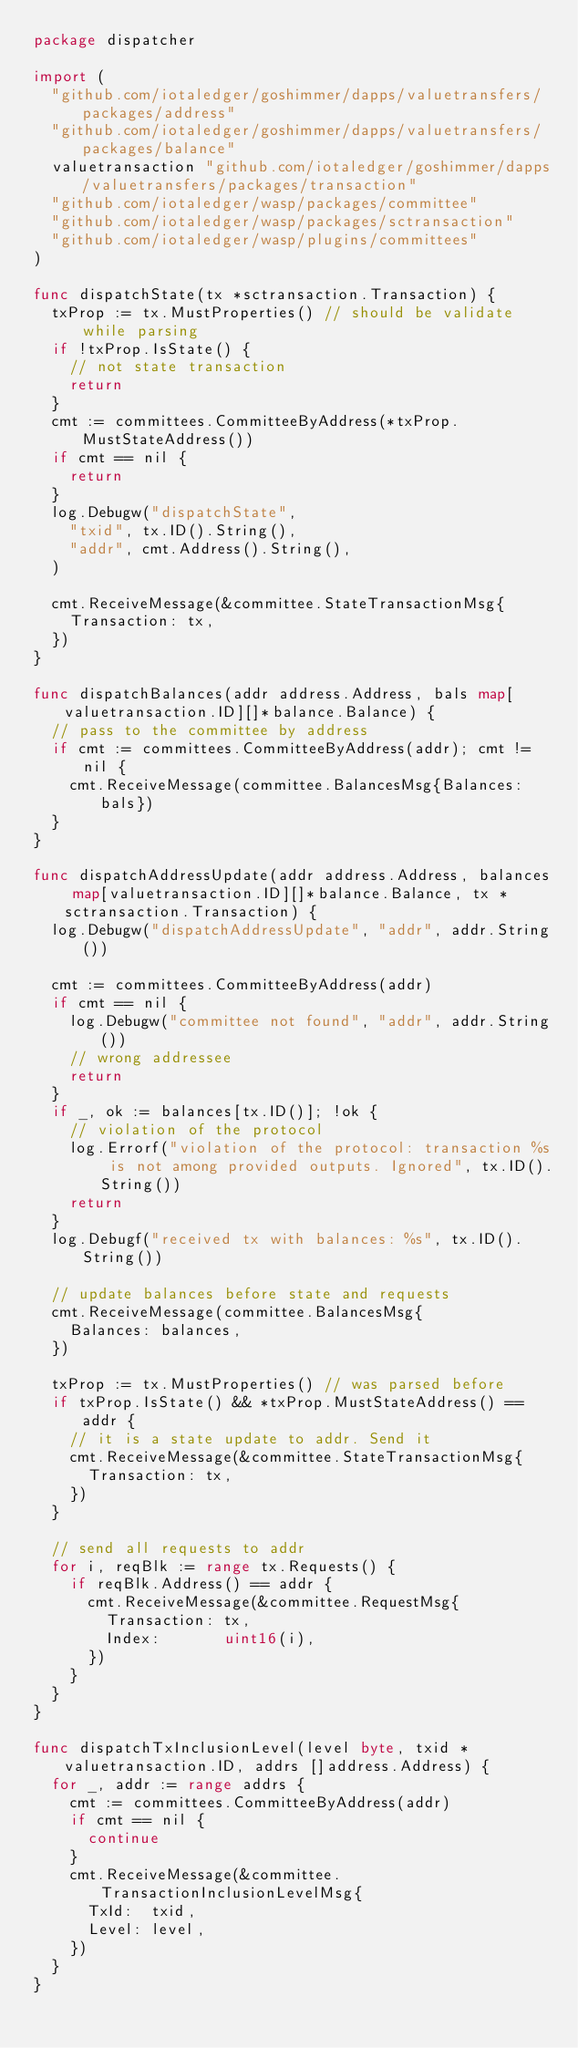Convert code to text. <code><loc_0><loc_0><loc_500><loc_500><_Go_>package dispatcher

import (
	"github.com/iotaledger/goshimmer/dapps/valuetransfers/packages/address"
	"github.com/iotaledger/goshimmer/dapps/valuetransfers/packages/balance"
	valuetransaction "github.com/iotaledger/goshimmer/dapps/valuetransfers/packages/transaction"
	"github.com/iotaledger/wasp/packages/committee"
	"github.com/iotaledger/wasp/packages/sctransaction"
	"github.com/iotaledger/wasp/plugins/committees"
)

func dispatchState(tx *sctransaction.Transaction) {
	txProp := tx.MustProperties() // should be validate while parsing
	if !txProp.IsState() {
		// not state transaction
		return
	}
	cmt := committees.CommitteeByAddress(*txProp.MustStateAddress())
	if cmt == nil {
		return
	}
	log.Debugw("dispatchState",
		"txid", tx.ID().String(),
		"addr", cmt.Address().String(),
	)

	cmt.ReceiveMessage(&committee.StateTransactionMsg{
		Transaction: tx,
	})
}

func dispatchBalances(addr address.Address, bals map[valuetransaction.ID][]*balance.Balance) {
	// pass to the committee by address
	if cmt := committees.CommitteeByAddress(addr); cmt != nil {
		cmt.ReceiveMessage(committee.BalancesMsg{Balances: bals})
	}
}

func dispatchAddressUpdate(addr address.Address, balances map[valuetransaction.ID][]*balance.Balance, tx *sctransaction.Transaction) {
	log.Debugw("dispatchAddressUpdate", "addr", addr.String())

	cmt := committees.CommitteeByAddress(addr)
	if cmt == nil {
		log.Debugw("committee not found", "addr", addr.String())
		// wrong addressee
		return
	}
	if _, ok := balances[tx.ID()]; !ok {
		// violation of the protocol
		log.Errorf("violation of the protocol: transaction %s is not among provided outputs. Ignored", tx.ID().String())
		return
	}
	log.Debugf("received tx with balances: %s", tx.ID().String())

	// update balances before state and requests
	cmt.ReceiveMessage(committee.BalancesMsg{
		Balances: balances,
	})

	txProp := tx.MustProperties() // was parsed before
	if txProp.IsState() && *txProp.MustStateAddress() == addr {
		// it is a state update to addr. Send it
		cmt.ReceiveMessage(&committee.StateTransactionMsg{
			Transaction: tx,
		})
	}

	// send all requests to addr
	for i, reqBlk := range tx.Requests() {
		if reqBlk.Address() == addr {
			cmt.ReceiveMessage(&committee.RequestMsg{
				Transaction: tx,
				Index:       uint16(i),
			})
		}
	}
}

func dispatchTxInclusionLevel(level byte, txid *valuetransaction.ID, addrs []address.Address) {
	for _, addr := range addrs {
		cmt := committees.CommitteeByAddress(addr)
		if cmt == nil {
			continue
		}
		cmt.ReceiveMessage(&committee.TransactionInclusionLevelMsg{
			TxId:  txid,
			Level: level,
		})
	}
}
</code> 